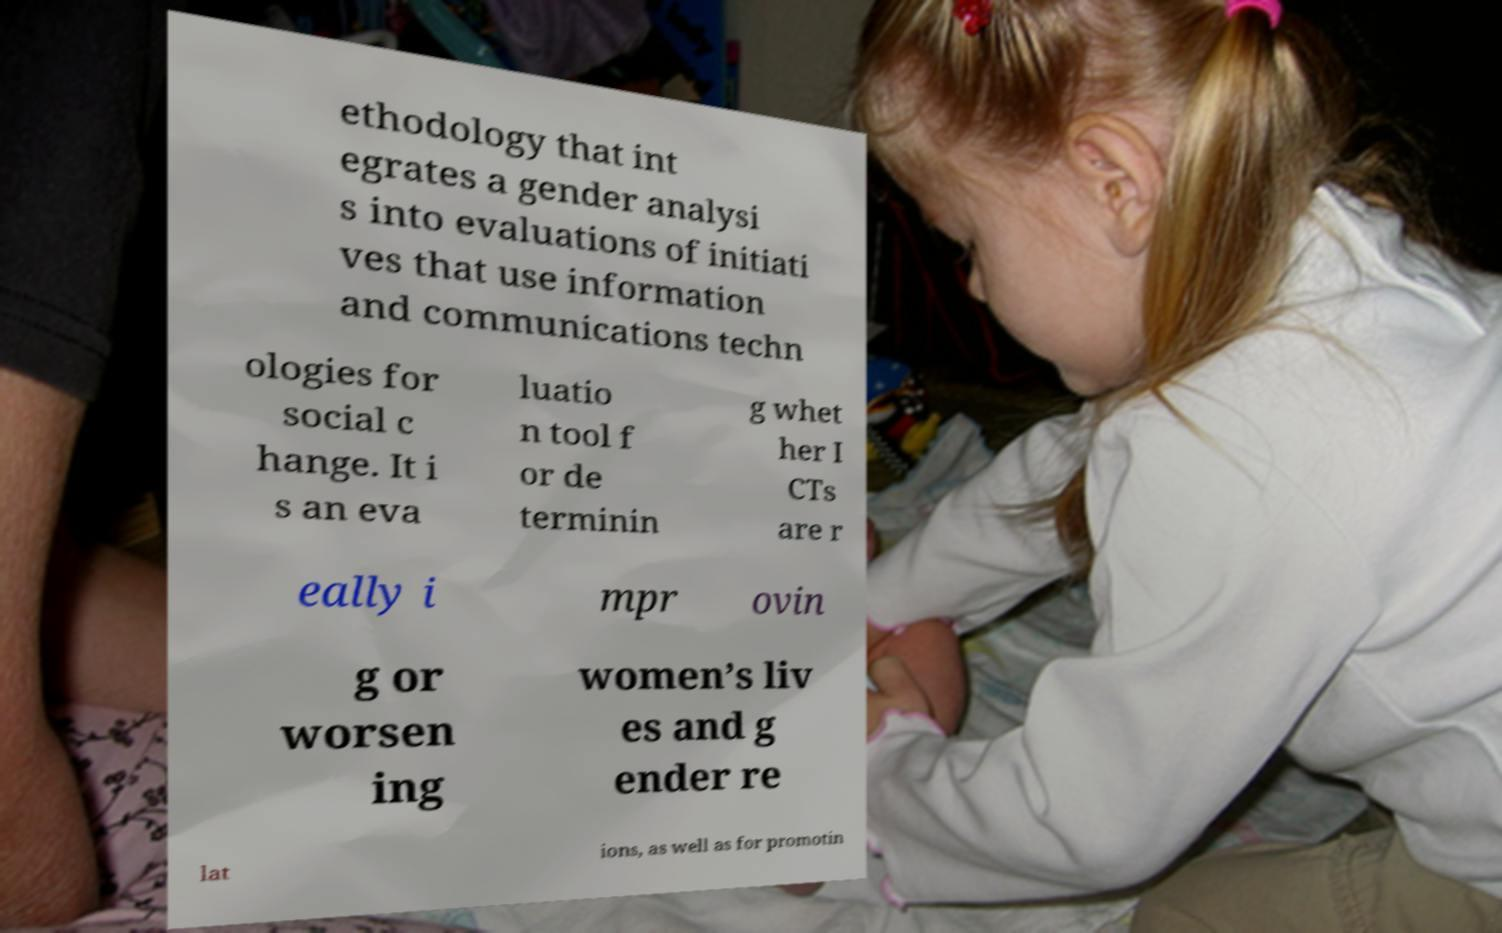Could you extract and type out the text from this image? ethodology that int egrates a gender analysi s into evaluations of initiati ves that use information and communications techn ologies for social c hange. It i s an eva luatio n tool f or de terminin g whet her I CTs are r eally i mpr ovin g or worsen ing women’s liv es and g ender re lat ions, as well as for promotin 